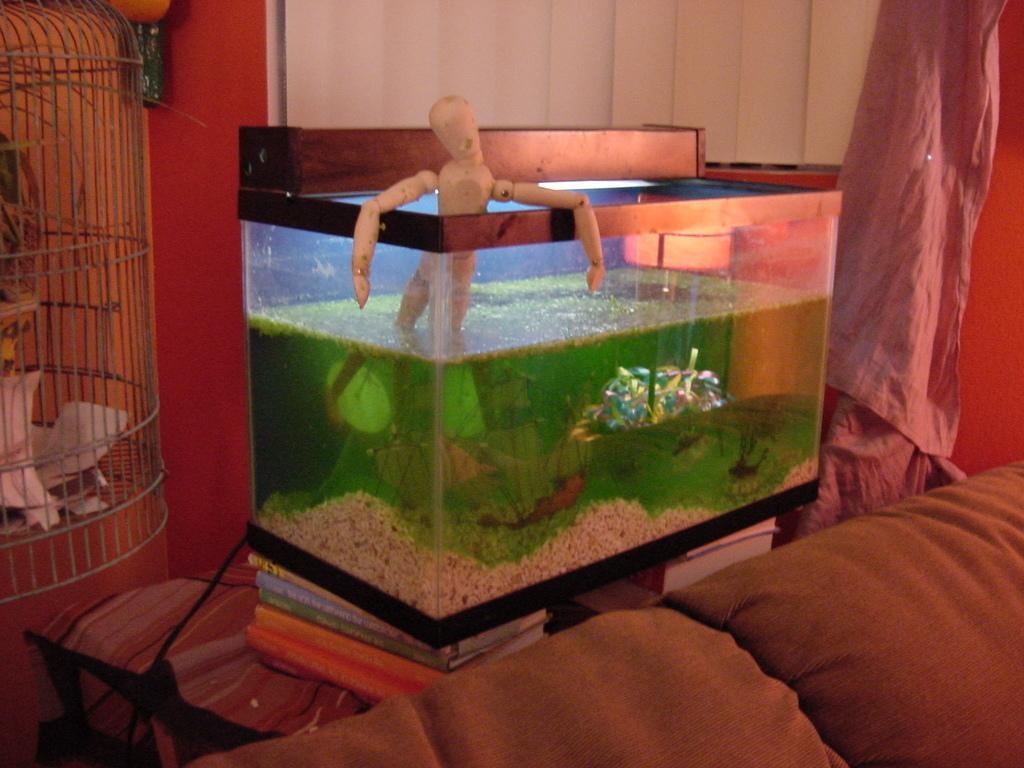Describe this image in one or two sentences. In this image there is a sofa, behind the sofa there is an aquarium, beside that there is a cage, in the background there is a wall and a curtain. 